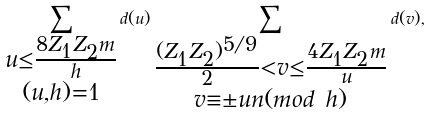<formula> <loc_0><loc_0><loc_500><loc_500>\sum _ { \substack { u \leq \frac { 8 Z _ { 1 } Z _ { 2 } m } { h } \\ ( u , h ) = 1 } } d ( u ) \sum _ { \substack { \frac { ( Z _ { 1 } Z _ { 2 } ) ^ { 5 / 9 } } { 2 } < v \leq \frac { 4 Z _ { 1 } Z _ { 2 } m } { u } \\ v \equiv \pm u n ( m o d \ h ) } } d ( v ) ,</formula> 